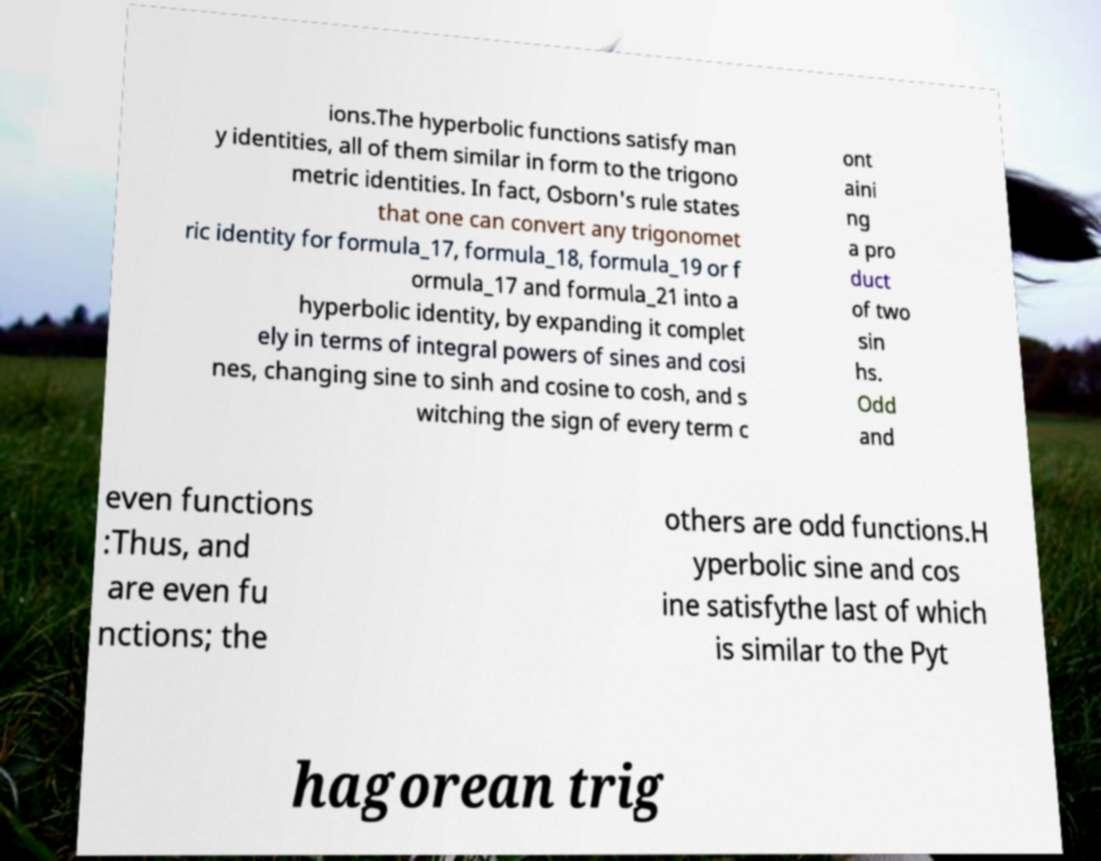Can you read and provide the text displayed in the image?This photo seems to have some interesting text. Can you extract and type it out for me? ions.The hyperbolic functions satisfy man y identities, all of them similar in form to the trigono metric identities. In fact, Osborn's rule states that one can convert any trigonomet ric identity for formula_17, formula_18, formula_19 or f ormula_17 and formula_21 into a hyperbolic identity, by expanding it complet ely in terms of integral powers of sines and cosi nes, changing sine to sinh and cosine to cosh, and s witching the sign of every term c ont aini ng a pro duct of two sin hs. Odd and even functions :Thus, and are even fu nctions; the others are odd functions.H yperbolic sine and cos ine satisfythe last of which is similar to the Pyt hagorean trig 